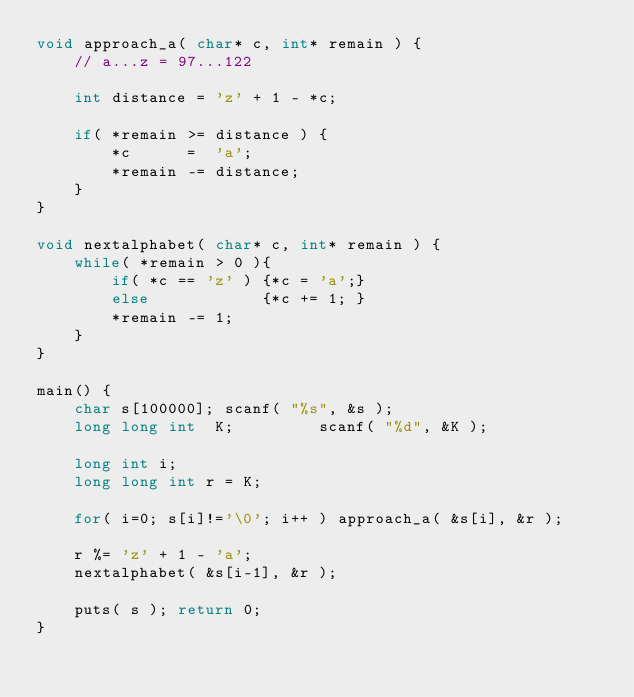<code> <loc_0><loc_0><loc_500><loc_500><_C_>void approach_a( char* c, int* remain ) {
	// a...z = 97...122

	int distance = 'z' + 1 - *c;

	if( *remain >= distance ) {
		*c      =  'a';
		*remain -= distance;
	}
}

void nextalphabet( char* c, int* remain ) {
	while( *remain > 0 ){
		if( *c == 'z' ) {*c = 'a';}
		else            {*c += 1; }
		*remain -= 1;
	}
}

main() {
	char s[100000]; scanf( "%s", &s );
	long long int  K;         scanf( "%d", &K );
	
	long int i;
	long long int r = K;

	for( i=0; s[i]!='\0'; i++ ) approach_a( &s[i], &r );

	r %= 'z' + 1 - 'a';
	nextalphabet( &s[i-1], &r );

	puts( s ); return 0;
}

</code> 